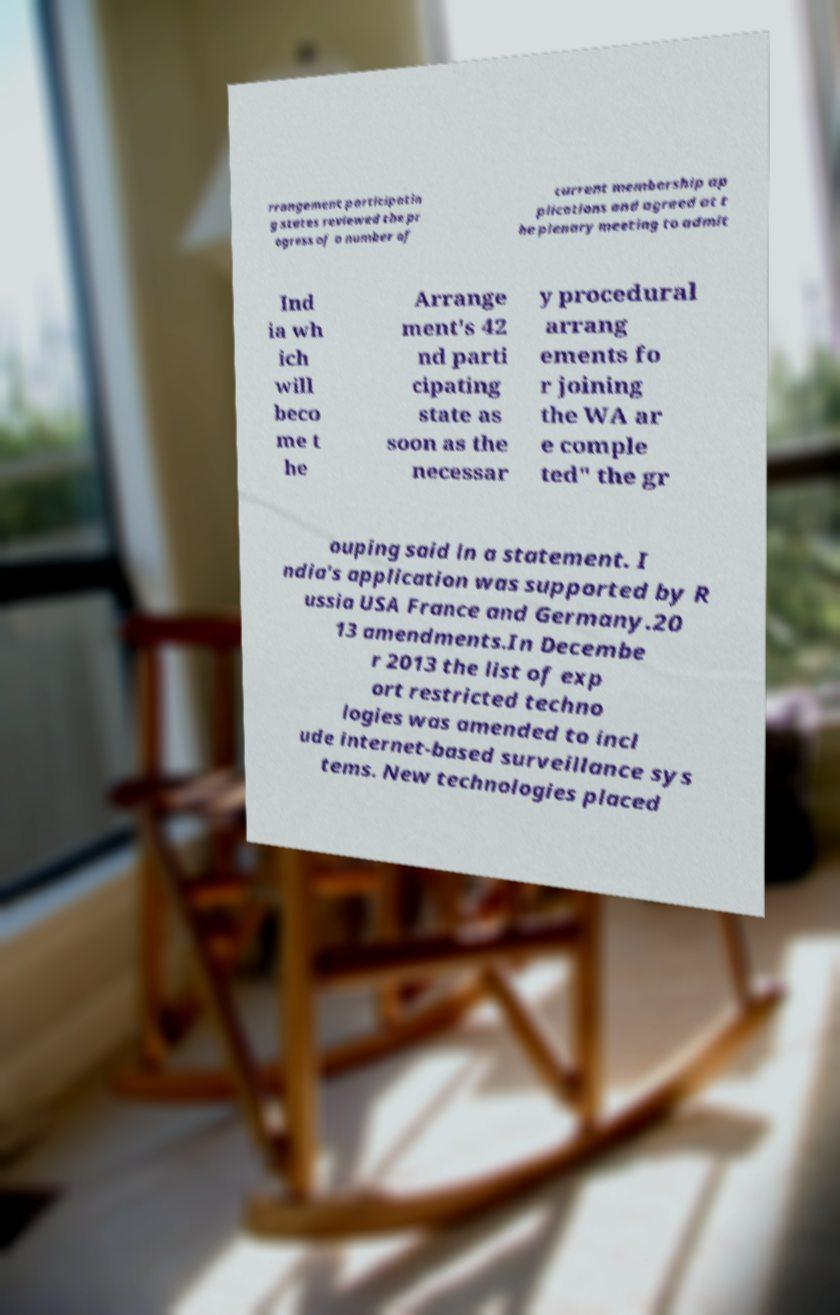Please identify and transcribe the text found in this image. rrangement participatin g states reviewed the pr ogress of a number of current membership ap plications and agreed at t he plenary meeting to admit Ind ia wh ich will beco me t he Arrange ment's 42 nd parti cipating state as soon as the necessar y procedural arrang ements fo r joining the WA ar e comple ted" the gr ouping said in a statement. I ndia's application was supported by R ussia USA France and Germany.20 13 amendments.In Decembe r 2013 the list of exp ort restricted techno logies was amended to incl ude internet-based surveillance sys tems. New technologies placed 